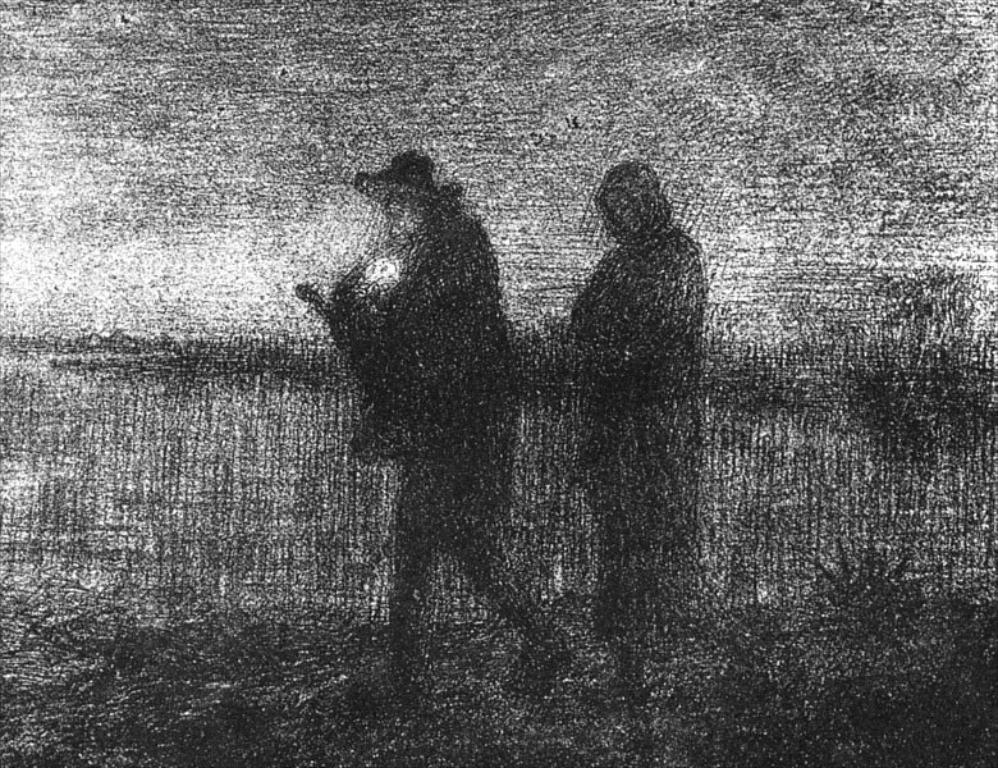How many people are in the image? There are two people in the image. What are the people doing in the image? The people are walking on the ground. Can you describe any accessories worn by the people? Yes, there is a cap visible in the image. What can be seen in the background of the image? The sky is visible in the background of the image. What type of marble is being used to pave the path in the image? There is no marble visible in the image; the people are walking on the ground, which is not specified as marble. Can you describe the fog in the image? There is no fog present in the image; the sky is visible in the background. 